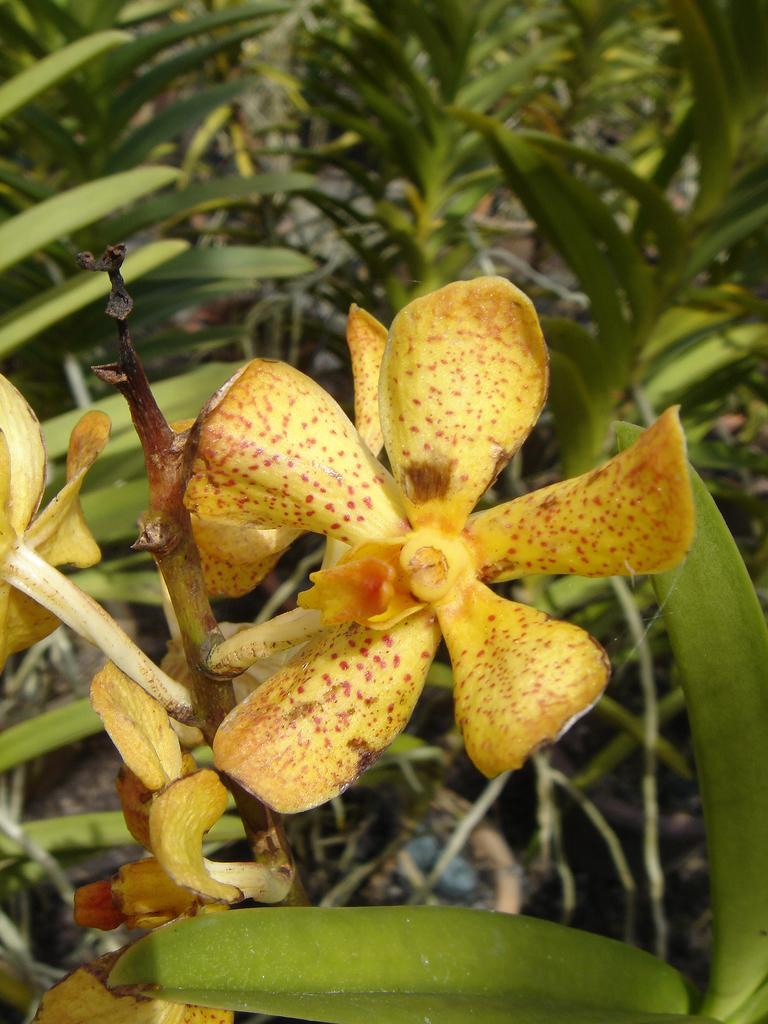What type of plant life is visible in the image? There are flowers in the image. Can you describe the leaf at the bottom of the image? Yes, there is a leaf at the bottom of the image. What can be seen in the background of the image? In the background of the image, there are leaves, branches, and other objects. How many ladybugs are sitting on the butter in the image? There are no ladybugs or butter present in the image. What type of mailbox can be seen in the image? There is no mailbox visible in the image. 